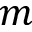Convert formula to latex. <formula><loc_0><loc_0><loc_500><loc_500>m</formula> 